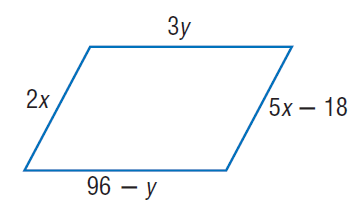Answer the mathemtical geometry problem and directly provide the correct option letter.
Question: Find x so that the quadrilateral is a parallelogram.
Choices: A: 6 B: 12 C: 24 D: 30 A 